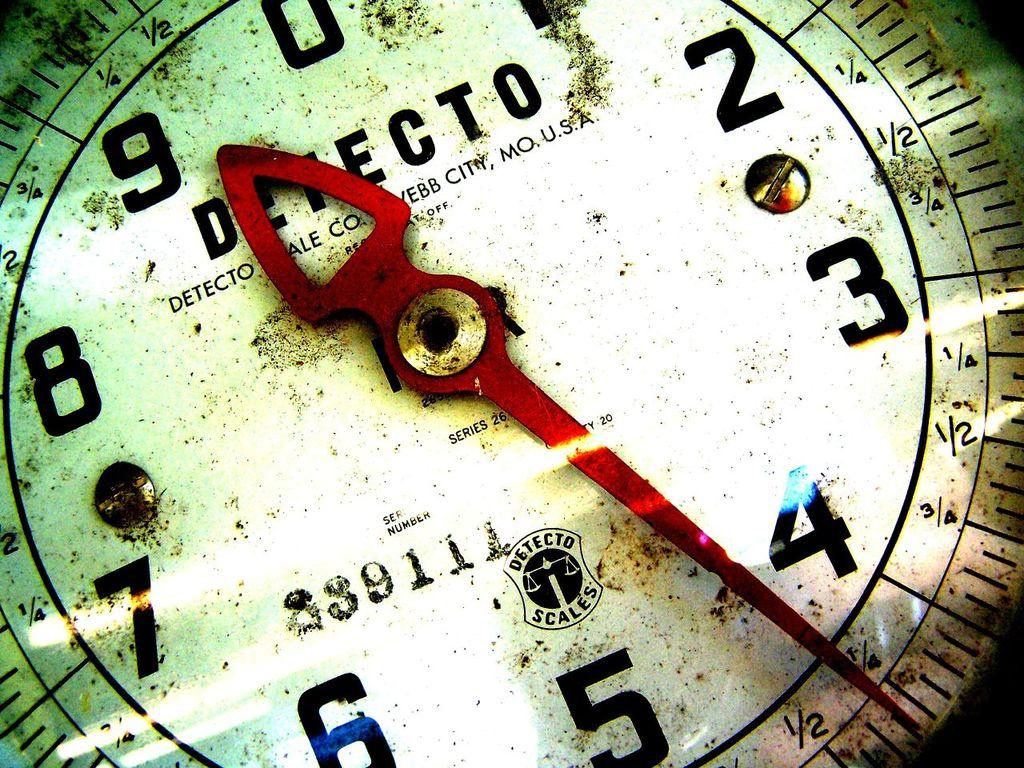<image>
Describe the image concisely. A dirty scale that is from a company Detecto 